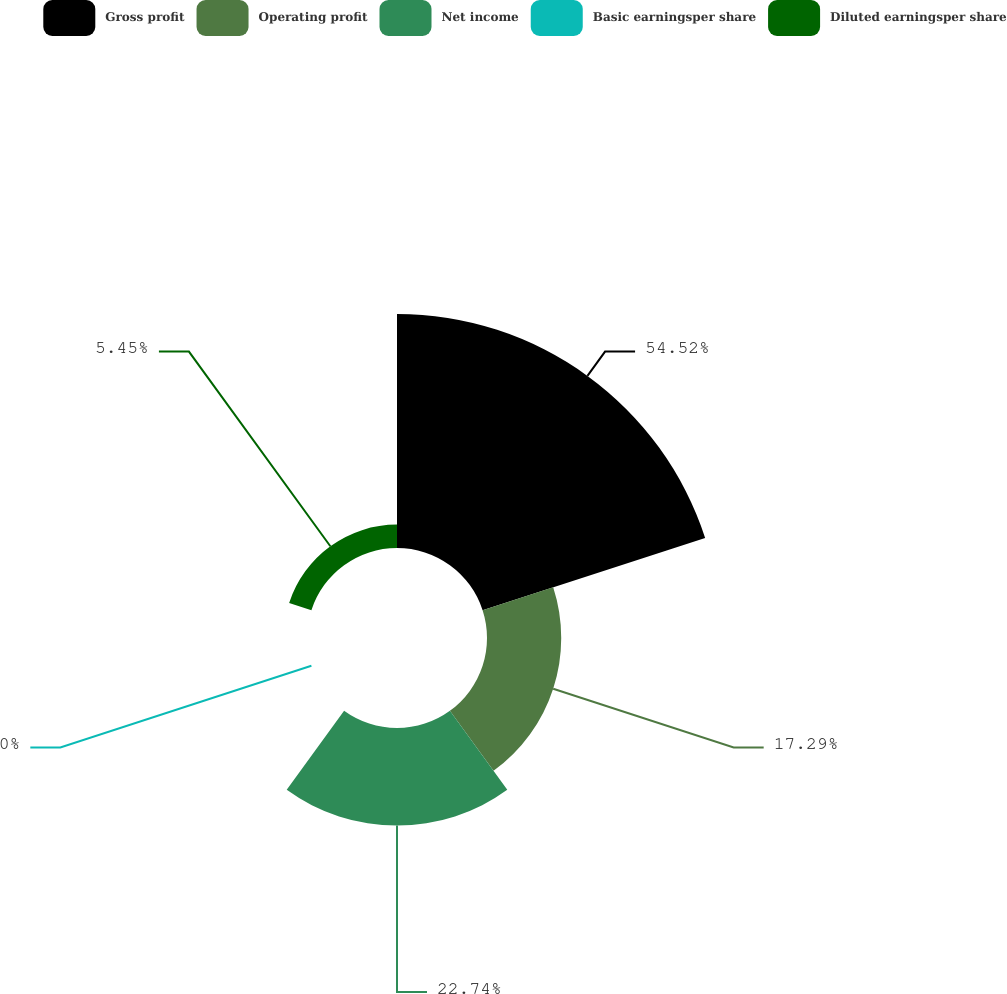Convert chart. <chart><loc_0><loc_0><loc_500><loc_500><pie_chart><fcel>Gross profit<fcel>Operating profit<fcel>Net income<fcel>Basic earningsper share<fcel>Diluted earningsper share<nl><fcel>54.51%<fcel>17.29%<fcel>22.74%<fcel>0.0%<fcel>5.45%<nl></chart> 